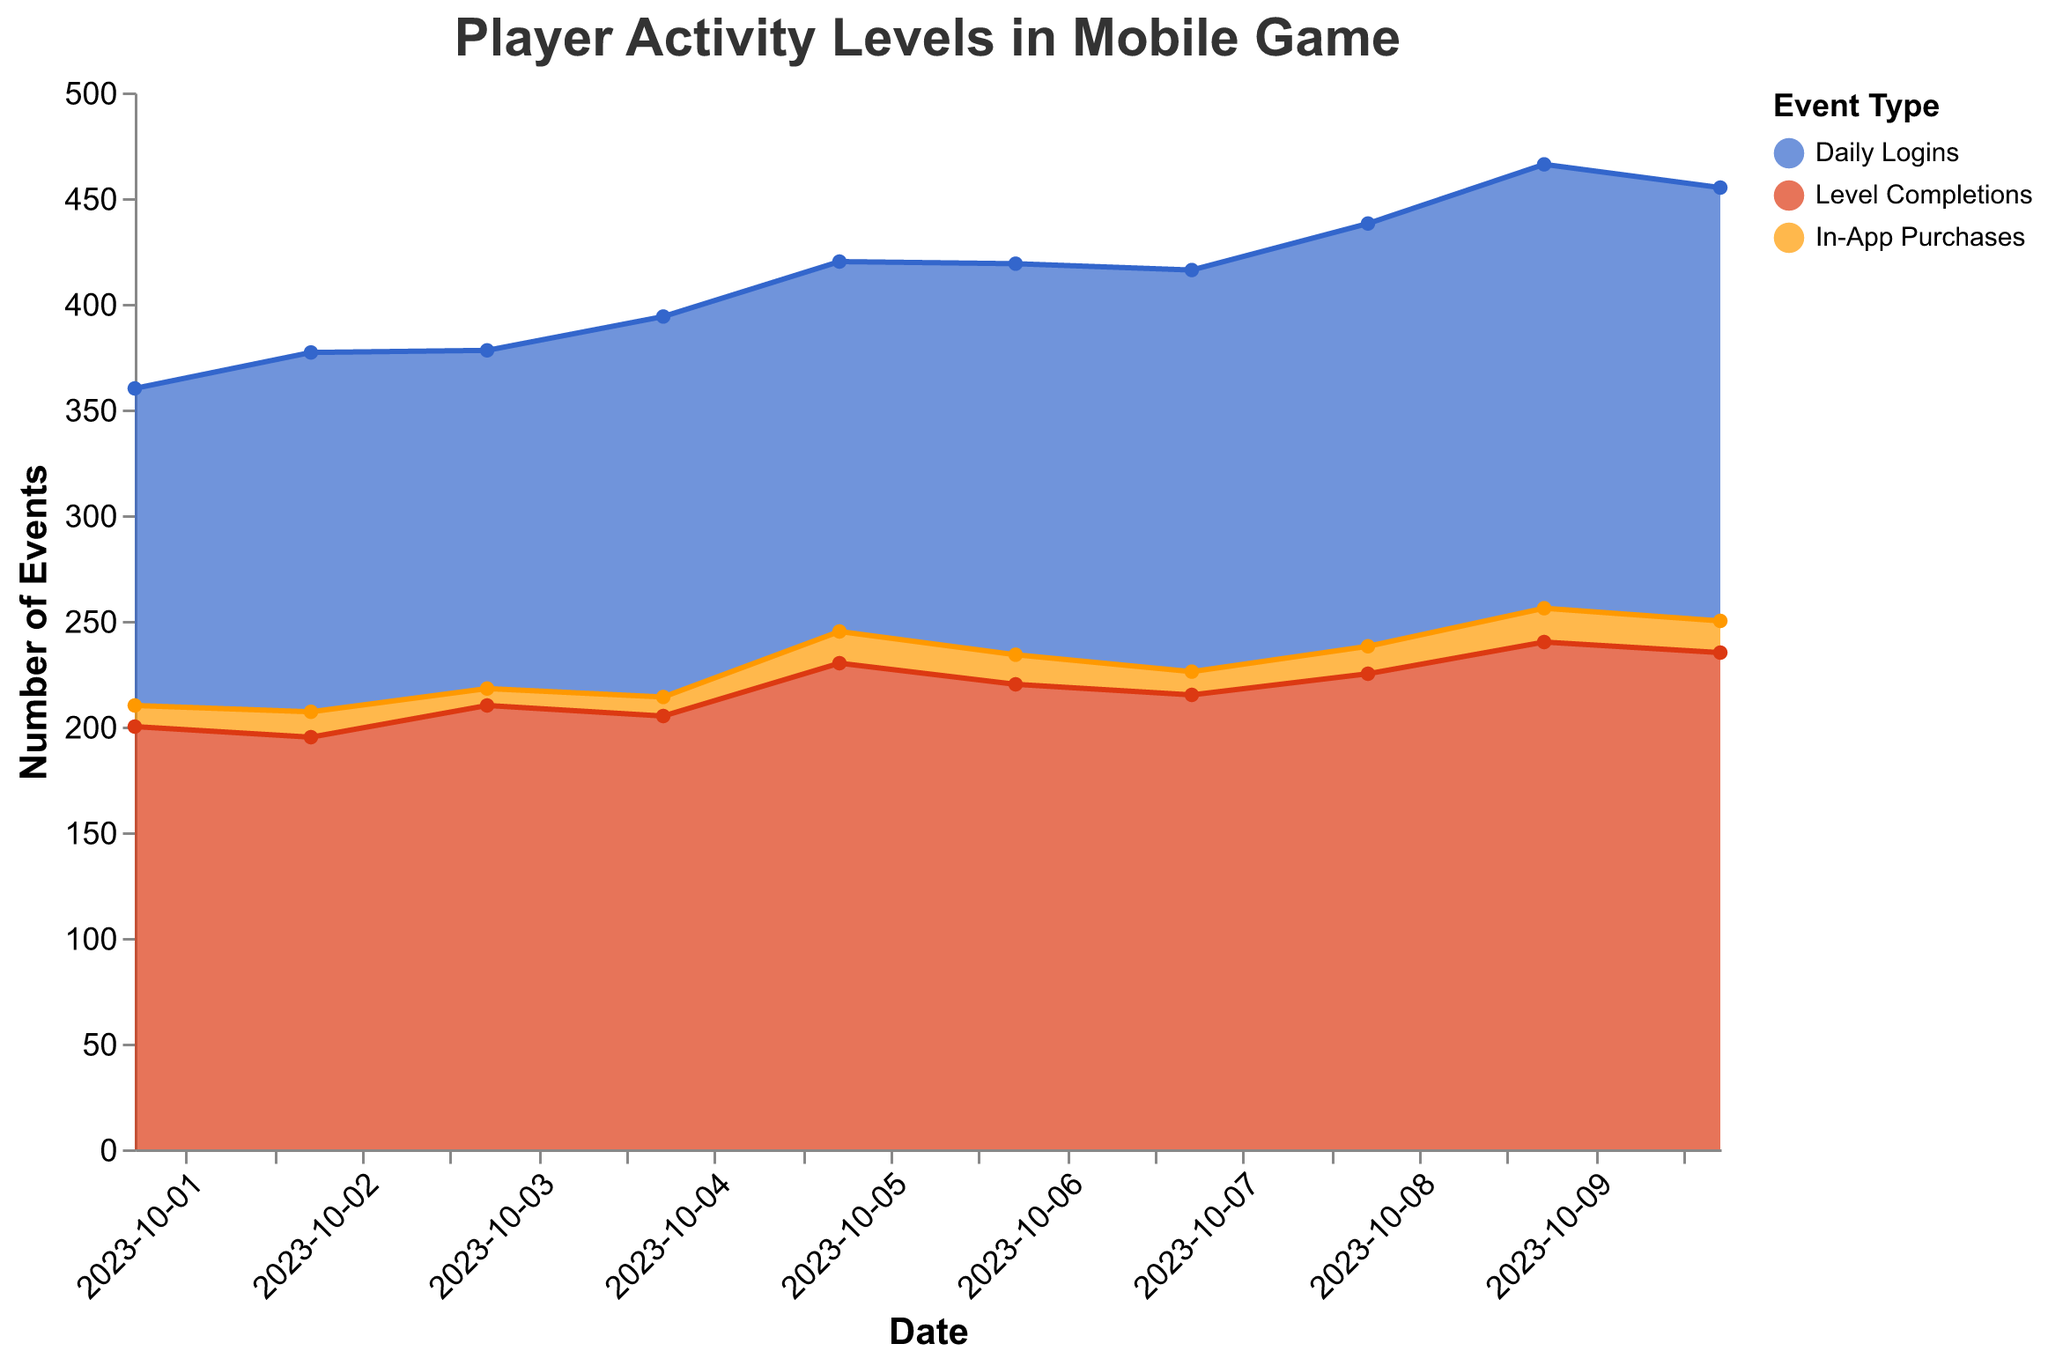What's the title of the chart? The title is provided at the top of the chart and it reads "Player Activity Levels in Mobile Game". This information helps us understand what the chart is about directly from the title.
Answer: Player Activity Levels in Mobile Game What are the three types of events shown in the chart? The legend on the right side of the chart lists the three types of events, which are "Daily Logins", "Level Completions", and "In-App Purchases".
Answer: Daily Logins, Level Completions, In-App Purchases Which day had the highest number of Level Completions? Looking at the highest point of the red area (representing Level Completions) on the y-axis, we see that "2023-10-09" had the highest number of completions at 240.
Answer: 2023-10-09 On which date did Daily Logins surpass 200 for the first time? By examining the blue area (representing Daily Logins), the first date the y-axis value surpasses 200 is October 8, 2023.
Answer: 2023-10-08 What is the difference in Daily Logins between 2023-10-09 and 2023-10-07? The number of Daily Logins on 2023-10-09 is 210 and on 2023-10-07 is 190. The difference is 210 - 190 = 20.
Answer: 20 Which event type shows the least variation over the observed period? By comparing the widths of the areas, the orange area (In-App Purchases) has the least variation, fluctuating between 8 and 16.
Answer: In-App Purchases What is the total number of Daily Logins for the period shown? Sum the Daily Logins values for all dates: 150 + 170 + 160 + 180 + 175 + 185 + 190 + 200 + 210 + 205 = 1825.
Answer: 1825 Compare the total number of In-App Purchases on 2023-10-02 and 2023-10-05. Which day had more, and by how much? In-App Purchases on 2023-10-02 was 12 and on 2023-10-05 was 15. The difference is 15 - 12 = 3, with 2023-10-05 having more.
Answer: 2023-10-05 by 3 